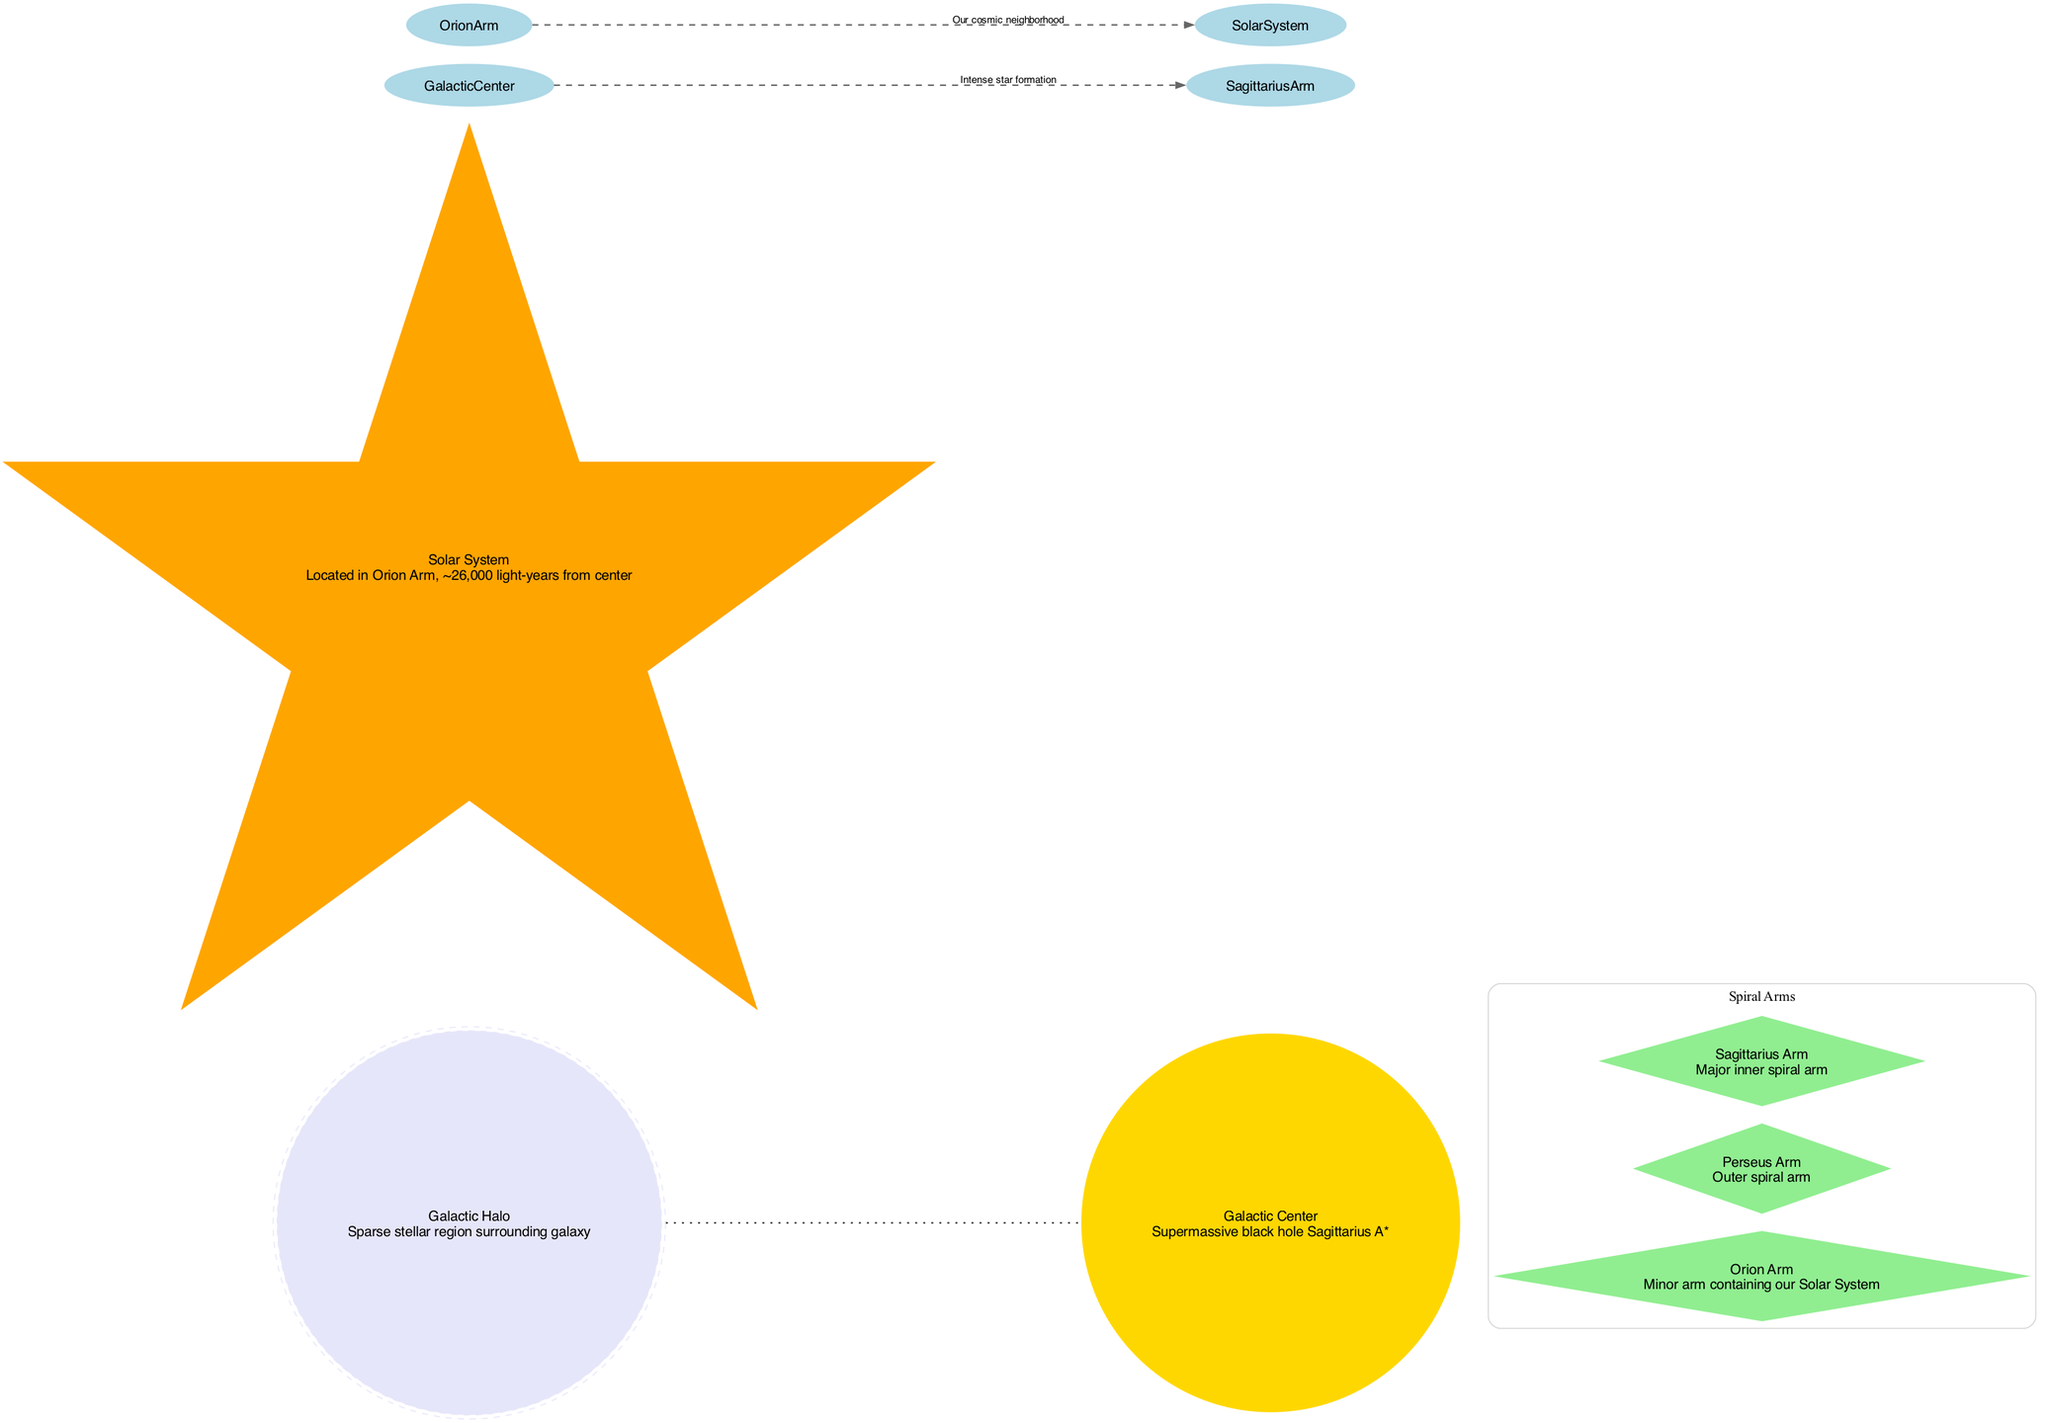What is located at the center of the Milky Way galaxy? The diagram identifies the Galactic Center as a supermassive black hole named Sagittarius A*. It emphasizes that this is a crucial landmark in the galaxy.
Answer: Galactic Center What is the name of the arm containing our Solar System? The diagram indicates that the Solar System is located in the Orion Arm. This is marked clearly in the design of the diagram.
Answer: Orion Arm How far is the Solar System from the Galactic Center? According to the Solar System's description in the diagram, it is approximately 26,000 light-years from the Galactic Center, which is specified clearly in the visual information.
Answer: ~26,000 light-years What type of celestial object is Sagittarius A*? The diagram explicitly states that Sagittarius A* is a supermassive black hole located at the Galactic Center, providing clarity about its nature.
Answer: Supermassive black hole Which spiral arm is the major inner arm? The diagram mentions the Sagittarius Arm as the major inner spiral arm. By highlighting this, it clearly defines its importance among the spiral structure.
Answer: Sagittarius Arm What does the connection between the Galactic Center and the Sagittarius Arm indicate? The diagram labels this connection as "Intense star formation," which suggests a significant process happening within this part of the galaxy. Following the labeled connection, it can be inferred that the activity is interlinked with the Galactic Center's features.
Answer: Intense star formation What kind of region surrounds the Milky Way galaxy? The diagram describes the Galactic Halo as a sparse stellar region surrounding the galaxy, indicating its structural components clearly.
Answer: Galactic Halo How many spiral arms are depicted in the diagram? Upon reviewing the diagram, there are three spiral arms listed—Perseus Arm, Orion Arm, and Sagittarius Arm—demonstrating the galaxy's spiral structure.
Answer: 3 What is the description provided for the Orion Arm? The diagram states that the Orion Arm is a minor arm containing our Solar System, thus highlighting its significance and position in the galaxy.
Answer: Minor arm containing our Solar System 